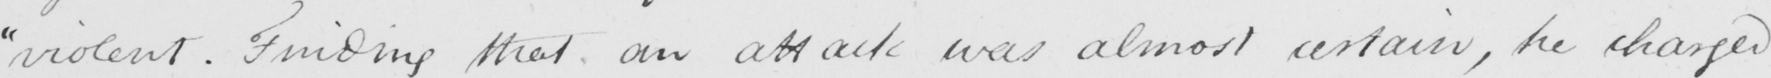What is written in this line of handwriting? " violent . Finding that an attack was almost certain , he charged 